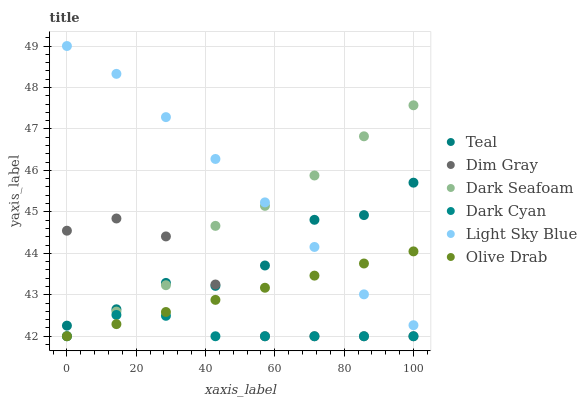Does Dark Cyan have the minimum area under the curve?
Answer yes or no. Yes. Does Light Sky Blue have the maximum area under the curve?
Answer yes or no. Yes. Does Dark Seafoam have the minimum area under the curve?
Answer yes or no. No. Does Dark Seafoam have the maximum area under the curve?
Answer yes or no. No. Is Olive Drab the smoothest?
Answer yes or no. Yes. Is Teal the roughest?
Answer yes or no. Yes. Is Dark Seafoam the smoothest?
Answer yes or no. No. Is Dark Seafoam the roughest?
Answer yes or no. No. Does Dim Gray have the lowest value?
Answer yes or no. Yes. Does Dark Seafoam have the lowest value?
Answer yes or no. No. Does Light Sky Blue have the highest value?
Answer yes or no. Yes. Does Dark Seafoam have the highest value?
Answer yes or no. No. Is Olive Drab less than Teal?
Answer yes or no. Yes. Is Dark Seafoam greater than Olive Drab?
Answer yes or no. Yes. Does Dark Cyan intersect Olive Drab?
Answer yes or no. Yes. Is Dark Cyan less than Olive Drab?
Answer yes or no. No. Is Dark Cyan greater than Olive Drab?
Answer yes or no. No. Does Olive Drab intersect Teal?
Answer yes or no. No. 